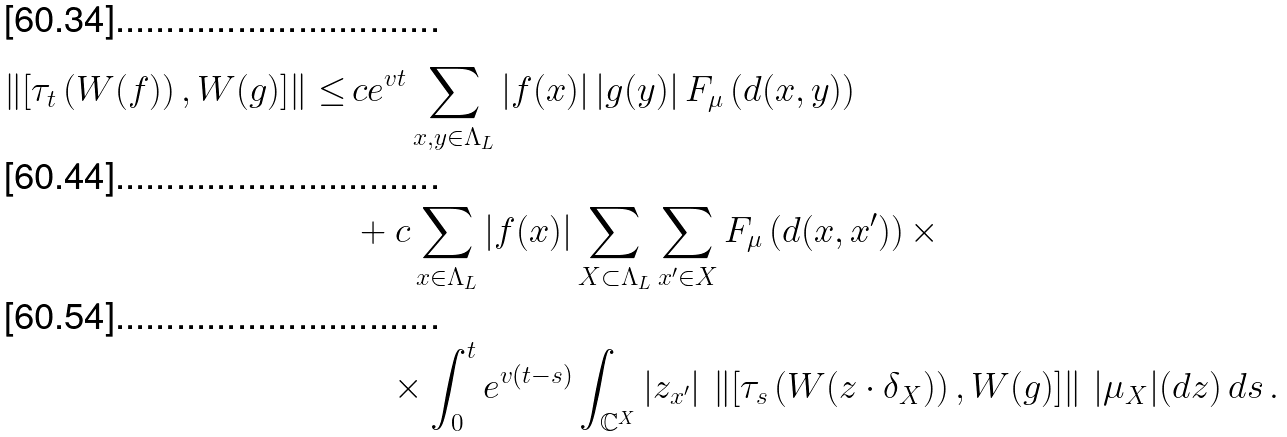<formula> <loc_0><loc_0><loc_500><loc_500>\left \| \left [ \tau _ { t } \left ( W ( f ) \right ) , W ( g ) \right ] \right \| \leq \, & c e ^ { v t } \sum _ { x , y \in \Lambda _ { L } } | f ( x ) | \, | g ( y ) | \, F _ { \mu } \left ( d ( x , y ) \right ) \\ & + c \sum _ { x \in \Lambda _ { L } } | f ( x ) | \sum _ { X \subset \Lambda _ { L } } \sum _ { x ^ { \prime } \in X } F _ { \mu } \left ( d ( x , x ^ { \prime } ) \right ) \times \\ & \quad \times \int _ { 0 } ^ { t } e ^ { v ( t - s ) } \int _ { \mathbb { C } ^ { X } } | z _ { x ^ { \prime } } | \, \left \| \left [ \tau _ { s } \left ( W ( z \cdot \delta _ { X } ) \right ) , W ( g ) \right ] \right \| \, | \mu _ { X } | ( d z ) \, d s \, .</formula> 